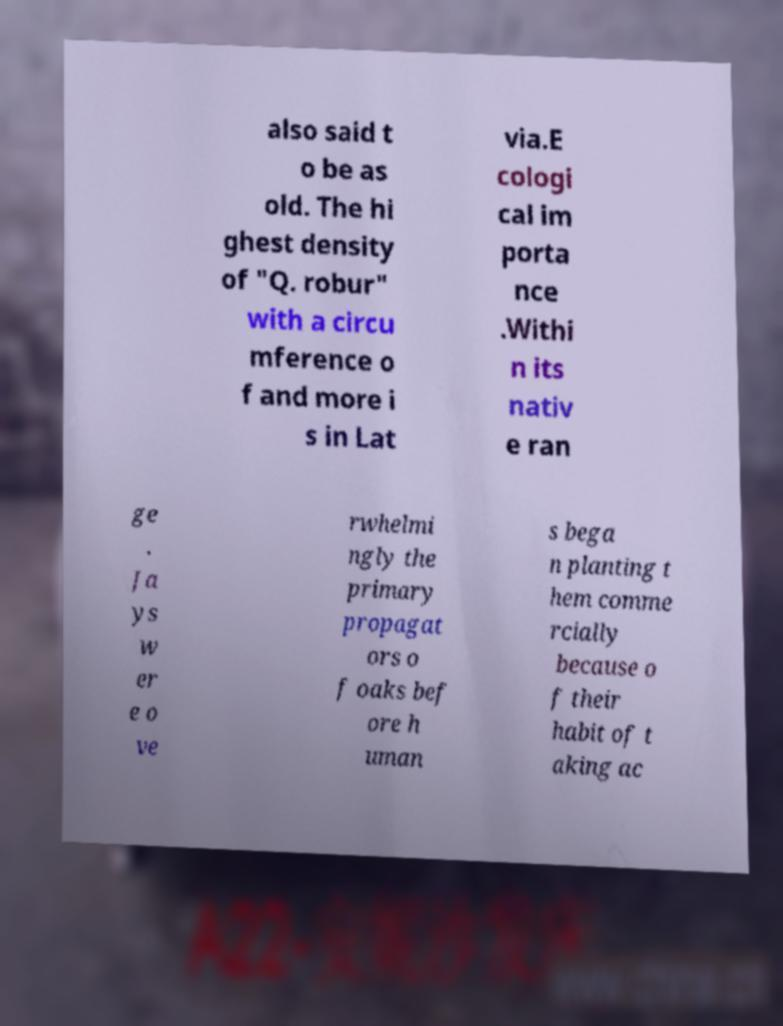Could you assist in decoding the text presented in this image and type it out clearly? also said t o be as old. The hi ghest density of "Q. robur" with a circu mference o f and more i s in Lat via.E cologi cal im porta nce .Withi n its nativ e ran ge . Ja ys w er e o ve rwhelmi ngly the primary propagat ors o f oaks bef ore h uman s bega n planting t hem comme rcially because o f their habit of t aking ac 